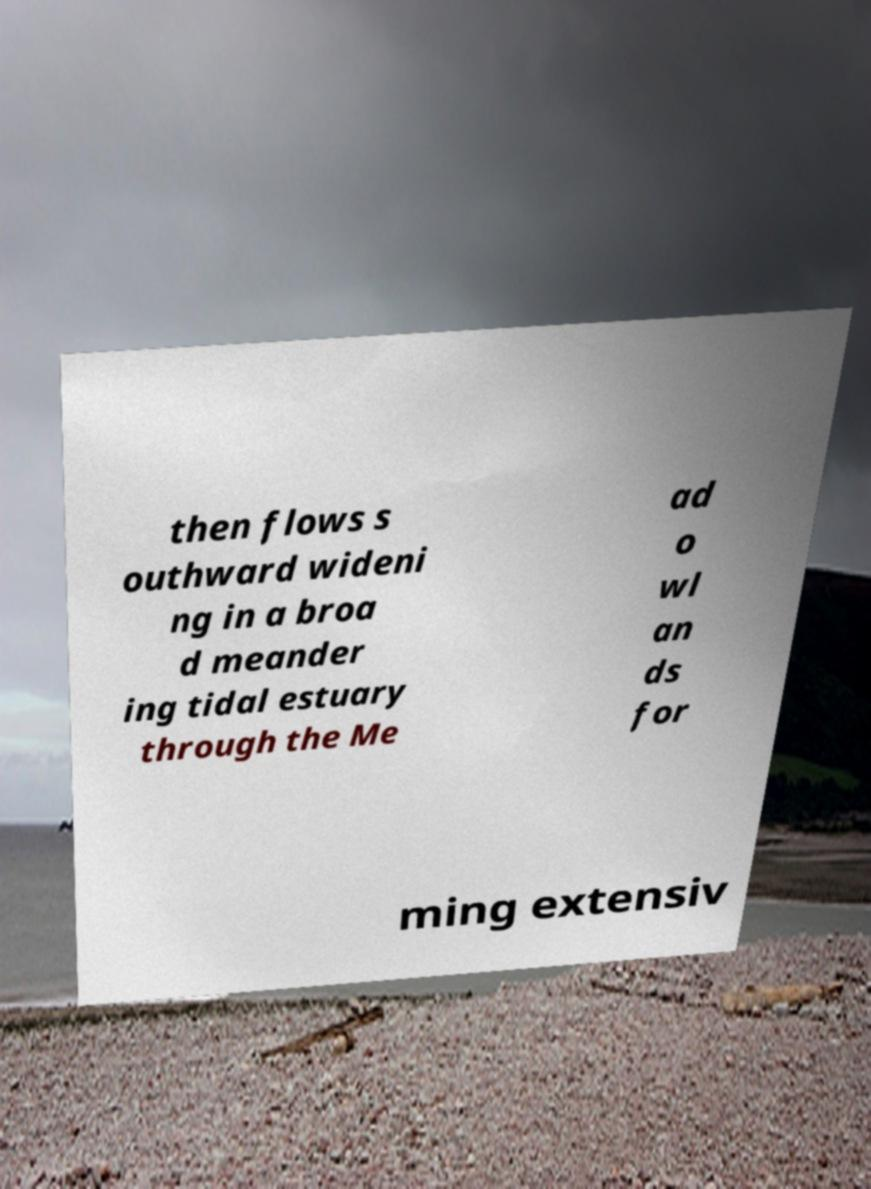Please read and relay the text visible in this image. What does it say? then flows s outhward wideni ng in a broa d meander ing tidal estuary through the Me ad o wl an ds for ming extensiv 